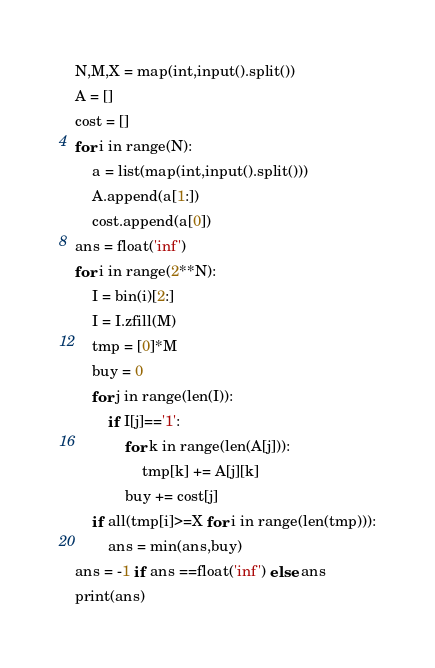<code> <loc_0><loc_0><loc_500><loc_500><_Python_>N,M,X = map(int,input().split())
A = []
cost = []
for i in range(N):
    a = list(map(int,input().split()))
    A.append(a[1:])
    cost.append(a[0])
ans = float('inf')
for i in range(2**N):
    I = bin(i)[2:]
    I = I.zfill(M)
    tmp = [0]*M
    buy = 0
    for j in range(len(I)):
        if I[j]=='1':
            for k in range(len(A[j])):
                tmp[k] += A[j][k]
            buy += cost[j]
    if all(tmp[i]>=X for i in range(len(tmp))):
        ans = min(ans,buy)
ans = -1 if ans ==float('inf') else ans
print(ans)</code> 